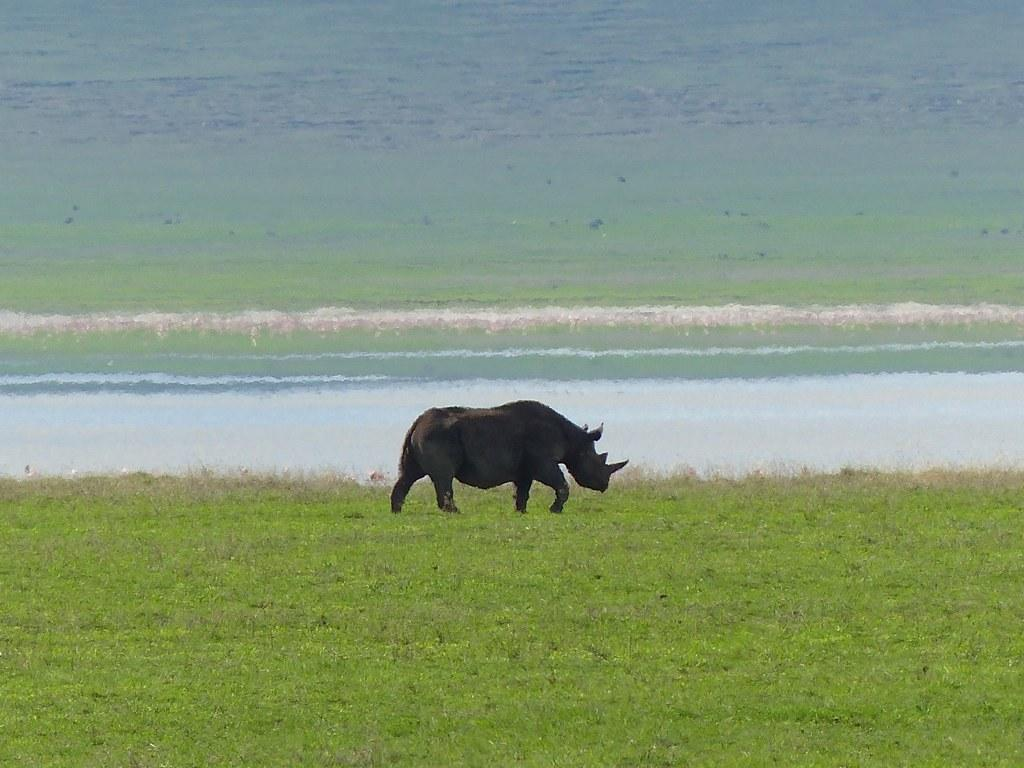What animal is present in the image? There is a rhino in the image. What is the rhino doing in the image? The rhino is walking in the image. What type of terrain is the rhino walking on? The rhino is on the grass in the image. What type of peace symbol can be seen in the image? There is no peace symbol present in the image; it features a rhino walking on grass. 